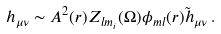<formula> <loc_0><loc_0><loc_500><loc_500>h _ { \mu \nu } \sim A ^ { 2 } ( r ) Z _ { l m _ { i } } ( \Omega ) \phi _ { m l } ( r ) { \tilde { h } } _ { \mu \nu } \, .</formula> 